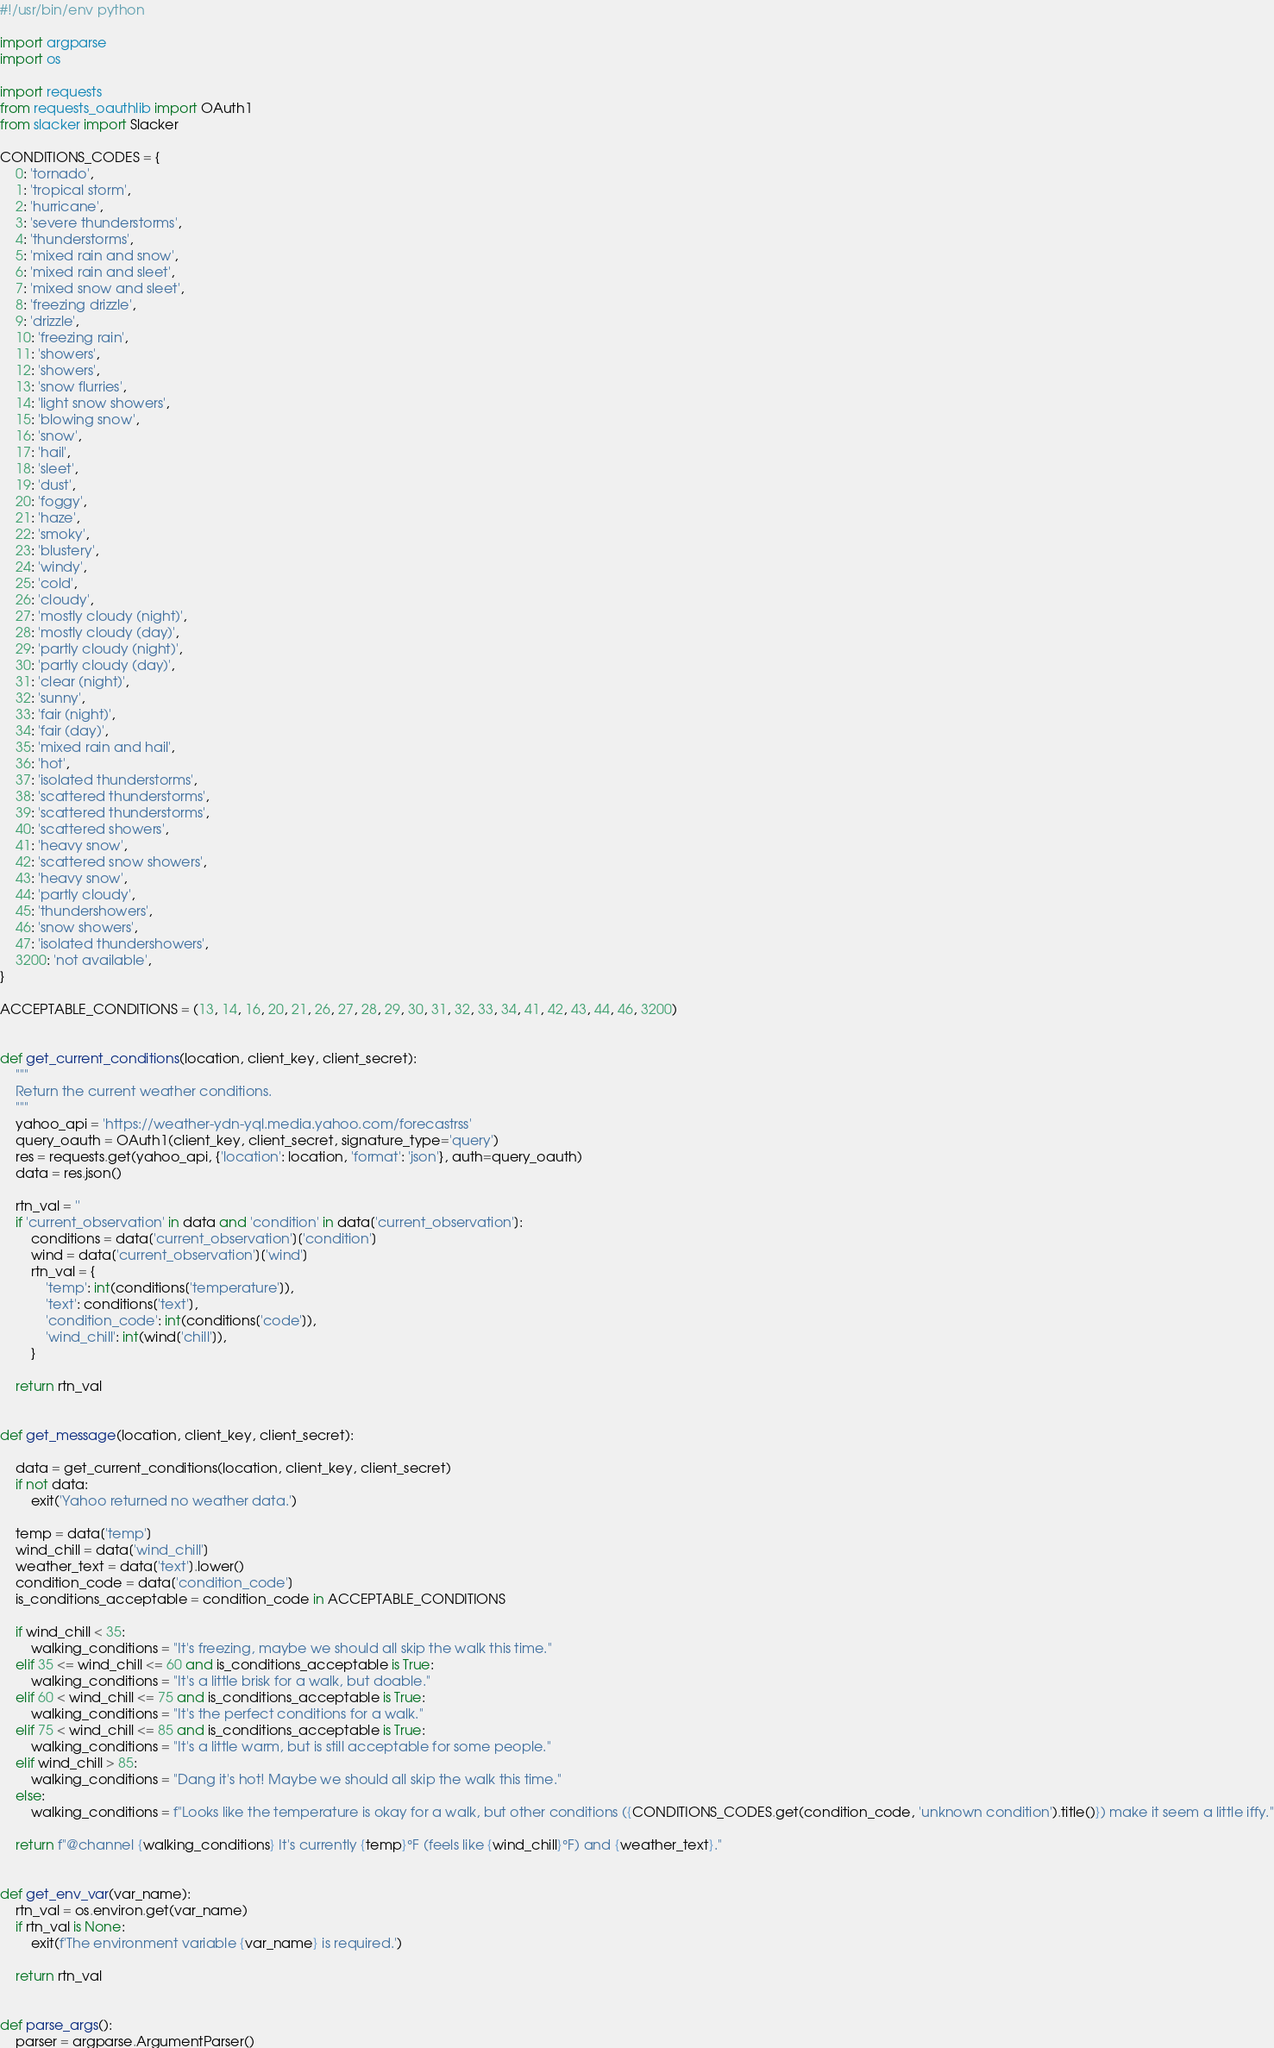Convert code to text. <code><loc_0><loc_0><loc_500><loc_500><_Python_>#!/usr/bin/env python

import argparse
import os

import requests
from requests_oauthlib import OAuth1
from slacker import Slacker

CONDITIONS_CODES = {
    0: 'tornado',
    1: 'tropical storm',
    2: 'hurricane',
    3: 'severe thunderstorms',
    4: 'thunderstorms',
    5: 'mixed rain and snow',
    6: 'mixed rain and sleet',
    7: 'mixed snow and sleet',
    8: 'freezing drizzle',
    9: 'drizzle',
    10: 'freezing rain',
    11: 'showers',
    12: 'showers',
    13: 'snow flurries',
    14: 'light snow showers',
    15: 'blowing snow',
    16: 'snow',
    17: 'hail',
    18: 'sleet',
    19: 'dust',
    20: 'foggy',
    21: 'haze',
    22: 'smoky',
    23: 'blustery',
    24: 'windy',
    25: 'cold',
    26: 'cloudy',
    27: 'mostly cloudy (night)',
    28: 'mostly cloudy (day)',
    29: 'partly cloudy (night)',
    30: 'partly cloudy (day)',
    31: 'clear (night)',
    32: 'sunny',
    33: 'fair (night)',
    34: 'fair (day)',
    35: 'mixed rain and hail',
    36: 'hot',
    37: 'isolated thunderstorms',
    38: 'scattered thunderstorms',
    39: 'scattered thunderstorms',
    40: 'scattered showers',
    41: 'heavy snow',
    42: 'scattered snow showers',
    43: 'heavy snow',
    44: 'partly cloudy',
    45: 'thundershowers',
    46: 'snow showers',
    47: 'isolated thundershowers',
    3200: 'not available',
}

ACCEPTABLE_CONDITIONS = (13, 14, 16, 20, 21, 26, 27, 28, 29, 30, 31, 32, 33, 34, 41, 42, 43, 44, 46, 3200)


def get_current_conditions(location, client_key, client_secret):
    """
    Return the current weather conditions.
    """
    yahoo_api = 'https://weather-ydn-yql.media.yahoo.com/forecastrss'
    query_oauth = OAuth1(client_key, client_secret, signature_type='query')
    res = requests.get(yahoo_api, {'location': location, 'format': 'json'}, auth=query_oauth)
    data = res.json()

    rtn_val = ''
    if 'current_observation' in data and 'condition' in data['current_observation']:
        conditions = data['current_observation']['condition']
        wind = data['current_observation']['wind']
        rtn_val = {
            'temp': int(conditions['temperature']),
            'text': conditions['text'],
            'condition_code': int(conditions['code']),
            'wind_chill': int(wind['chill']),
        }

    return rtn_val


def get_message(location, client_key, client_secret):

    data = get_current_conditions(location, client_key, client_secret)
    if not data:
        exit('Yahoo returned no weather data.')

    temp = data['temp']
    wind_chill = data['wind_chill']
    weather_text = data['text'].lower()
    condition_code = data['condition_code']
    is_conditions_acceptable = condition_code in ACCEPTABLE_CONDITIONS

    if wind_chill < 35:
        walking_conditions = "It's freezing, maybe we should all skip the walk this time."
    elif 35 <= wind_chill <= 60 and is_conditions_acceptable is True:
        walking_conditions = "It's a little brisk for a walk, but doable."
    elif 60 < wind_chill <= 75 and is_conditions_acceptable is True:
        walking_conditions = "It's the perfect conditions for a walk."
    elif 75 < wind_chill <= 85 and is_conditions_acceptable is True:
        walking_conditions = "It's a little warm, but is still acceptable for some people."
    elif wind_chill > 85:
        walking_conditions = "Dang it's hot! Maybe we should all skip the walk this time."
    else:
        walking_conditions = f"Looks like the temperature is okay for a walk, but other conditions ({CONDITIONS_CODES.get(condition_code, 'unknown condition').title()}) make it seem a little iffy."

    return f"@channel {walking_conditions} It's currently {temp}°F (feels like {wind_chill}°F) and {weather_text}."


def get_env_var(var_name):
    rtn_val = os.environ.get(var_name)
    if rtn_val is None:
        exit(f'The environment variable {var_name} is required.')

    return rtn_val


def parse_args():
    parser = argparse.ArgumentParser()</code> 